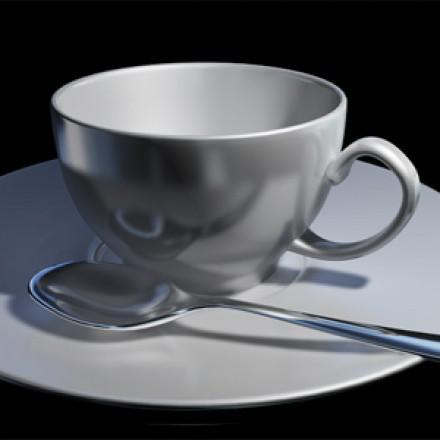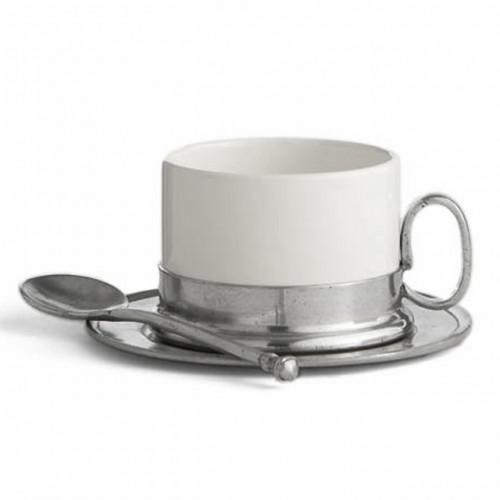The first image is the image on the left, the second image is the image on the right. Considering the images on both sides, is "In each image there is a spoon laid next to the cup on the plate." valid? Answer yes or no. Yes. The first image is the image on the left, the second image is the image on the right. Examine the images to the left and right. Is the description "Both cups have a spoon sitting on their saucer." accurate? Answer yes or no. Yes. 